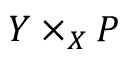Convert formula to latex. <formula><loc_0><loc_0><loc_500><loc_500>Y \times _ { X } P</formula> 